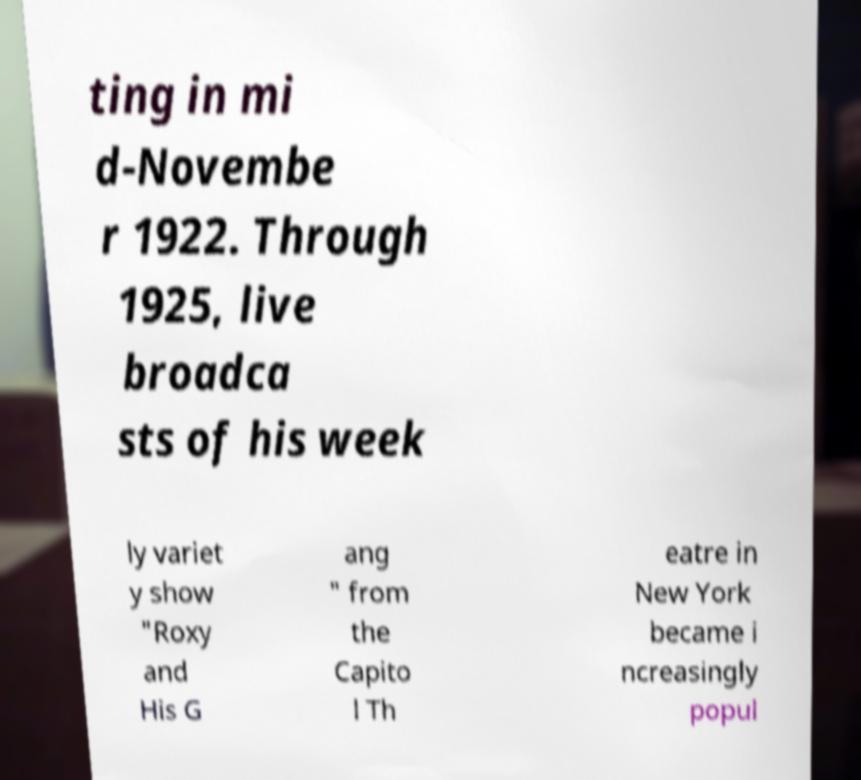Can you accurately transcribe the text from the provided image for me? ting in mi d-Novembe r 1922. Through 1925, live broadca sts of his week ly variet y show "Roxy and His G ang " from the Capito l Th eatre in New York became i ncreasingly popul 